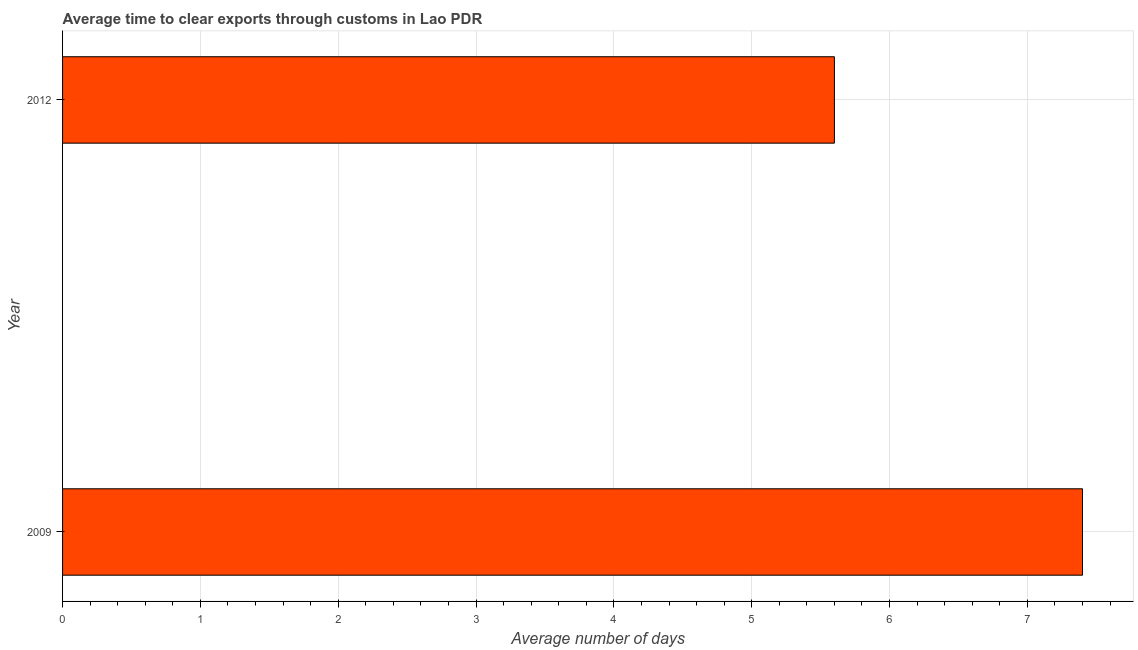Does the graph contain any zero values?
Ensure brevity in your answer.  No. What is the title of the graph?
Your response must be concise. Average time to clear exports through customs in Lao PDR. What is the label or title of the X-axis?
Keep it short and to the point. Average number of days. What is the time to clear exports through customs in 2012?
Your response must be concise. 5.6. In which year was the time to clear exports through customs maximum?
Give a very brief answer. 2009. What is the difference between the time to clear exports through customs in 2009 and 2012?
Provide a succinct answer. 1.8. What is the median time to clear exports through customs?
Provide a succinct answer. 6.5. Do a majority of the years between 2009 and 2012 (inclusive) have time to clear exports through customs greater than 1.6 days?
Provide a succinct answer. Yes. What is the ratio of the time to clear exports through customs in 2009 to that in 2012?
Give a very brief answer. 1.32. Is the time to clear exports through customs in 2009 less than that in 2012?
Your answer should be compact. No. In how many years, is the time to clear exports through customs greater than the average time to clear exports through customs taken over all years?
Keep it short and to the point. 1. How many bars are there?
Your answer should be compact. 2. Are all the bars in the graph horizontal?
Provide a succinct answer. Yes. Are the values on the major ticks of X-axis written in scientific E-notation?
Offer a terse response. No. What is the difference between the Average number of days in 2009 and 2012?
Your answer should be compact. 1.8. What is the ratio of the Average number of days in 2009 to that in 2012?
Your answer should be compact. 1.32. 